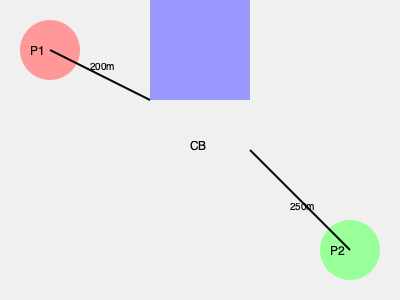Given the campus map above, where P1 and P2 are parking lots, and CB is your class building, what is the shortest total distance (in meters) you would need to walk if you had to check both parking lots before going to your class? To solve this problem, we need to consider all possible routes and calculate their distances:

1. Route 1: P1 → P2 → CB
   Distance = P1 to P2 + P2 to CB
   
2. Route 2: P2 → P1 → CB
   Distance = P2 to P1 + P1 to CB

Let's calculate these distances:

1. P1 to P2 (direct):
   Using the Pythagorean theorem: $\sqrt{(350-50)^2 + (250-50)^2} = \sqrt{300^2 + 200^2} = \sqrt{130000} \approx 360.55$ m

2. P1 to CB: 200 m (given)

3. P2 to CB: 250 m (given)

Now, let's calculate the total distances for each route:

Route 1: P1 → P2 → CB
Total distance = 360.55 + 250 = 610.55 m

Route 2: P2 → P1 → CB
Total distance = 360.55 + 200 = 560.55 m

The shortest total distance is Route 2, which is approximately 560.55 meters.
Answer: 560.55 m 